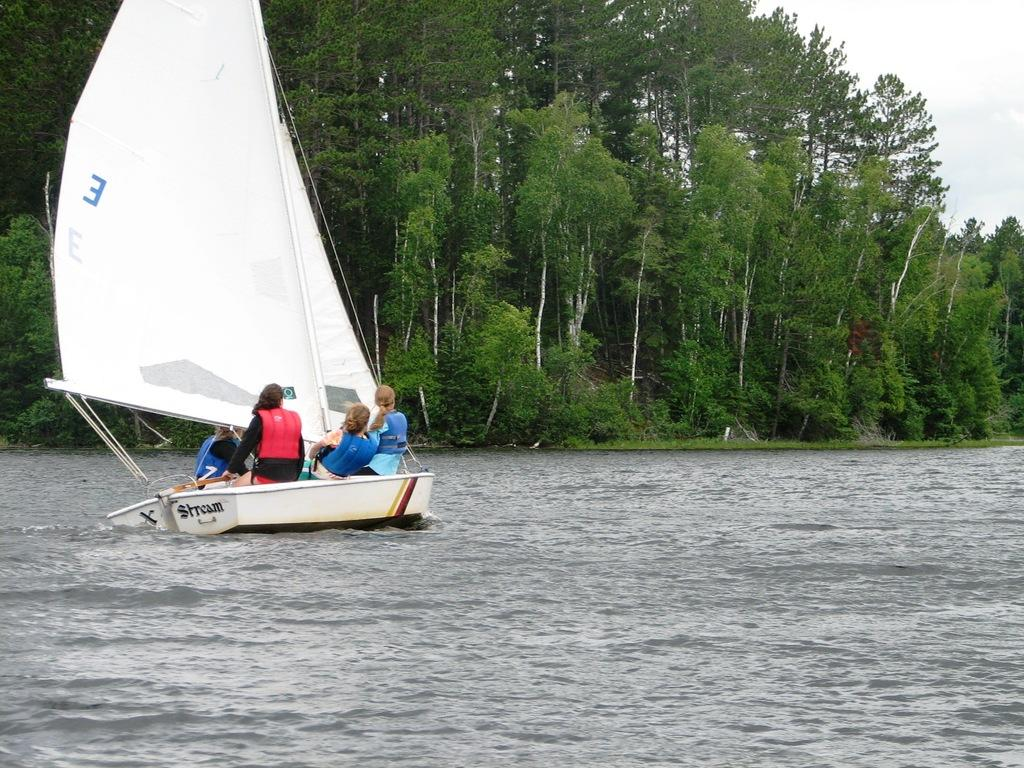What type of vehicles are on the water in the image? There are two white color boats on the water in the image. Are there any people in the boats? Yes, there are persons in the boats. Where are the boats located in the image? The boats are on the left side of the image. What can be seen in the background of the image? There are trees and plants in the background of the image. What is visible in the sky in the image? There are clouds in the sky. What type of pencil is being used by the person in the boat to draw the condition of the water? There is no pencil or drawing activity present in the image. 